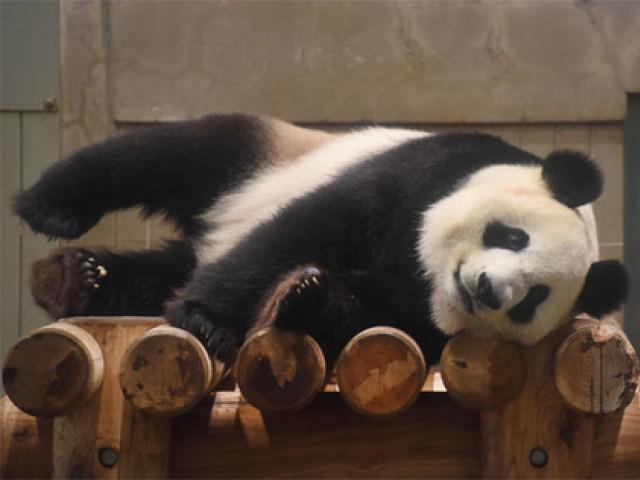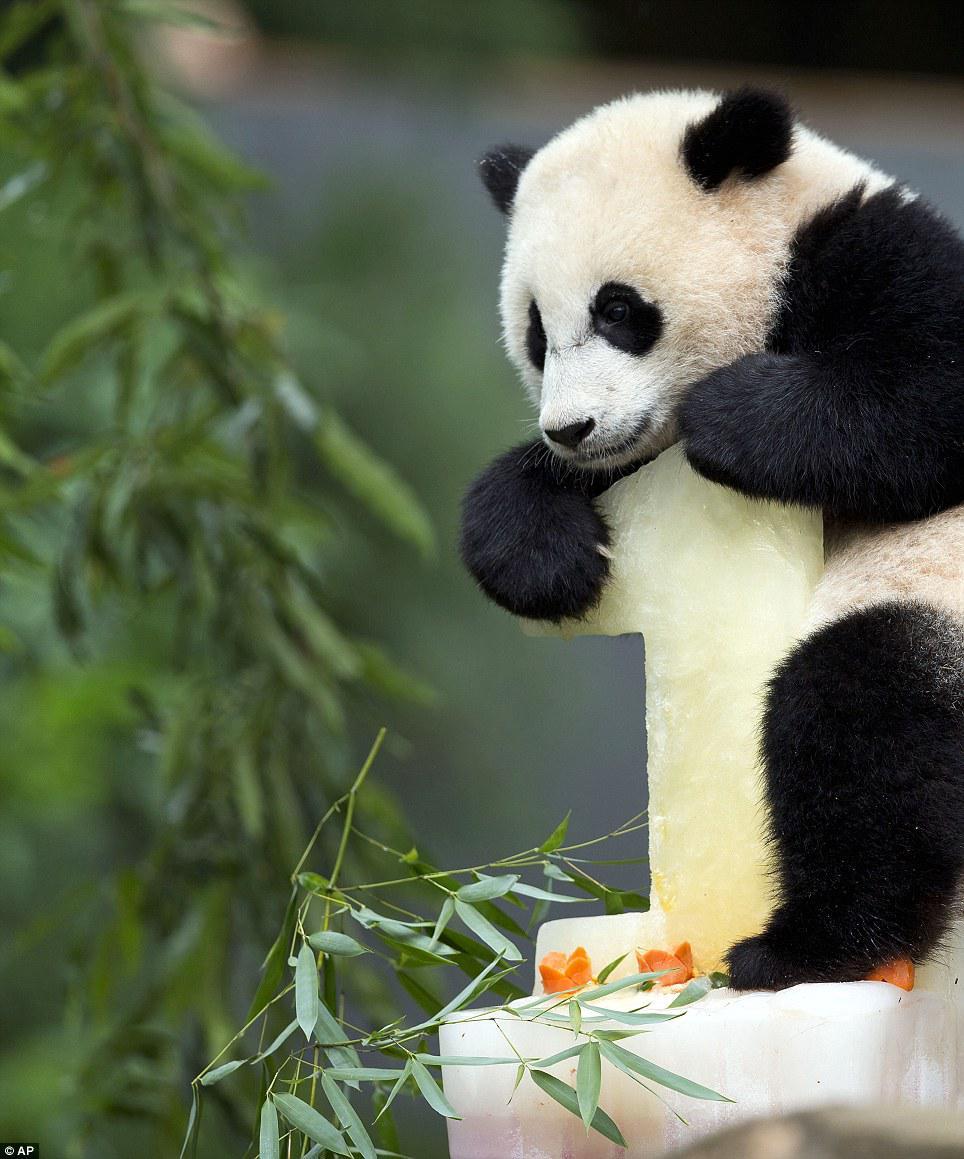The first image is the image on the left, the second image is the image on the right. Examine the images to the left and right. Is the description "There is at least one panda up in a tree." accurate? Answer yes or no. No. The first image is the image on the left, the second image is the image on the right. Evaluate the accuracy of this statement regarding the images: "Each image contains only one panda, and one image shows a panda with its paws draped over something for support.". Is it true? Answer yes or no. Yes. 